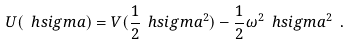<formula> <loc_0><loc_0><loc_500><loc_500>U ( \ h s i g m a ) = V ( \frac { 1 } { 2 } \ h s i g m a ^ { 2 } ) - \frac { 1 } { 2 } \omega ^ { 2 } \ h s i g m a ^ { 2 } \ .</formula> 